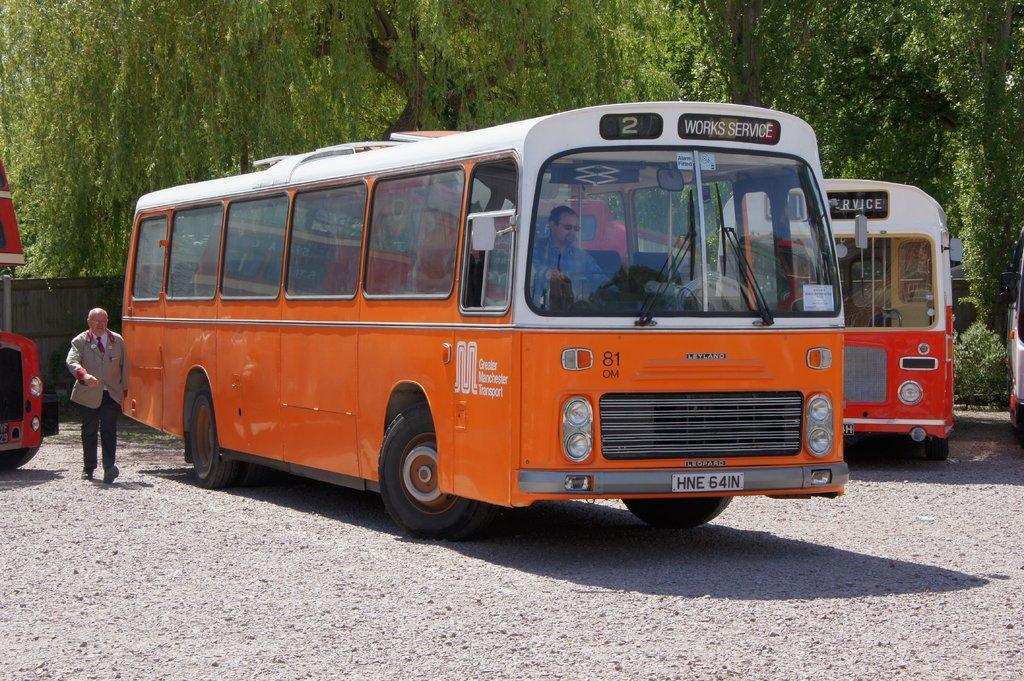<image>
Relay a brief, clear account of the picture shown. a bus that says works service at the top 